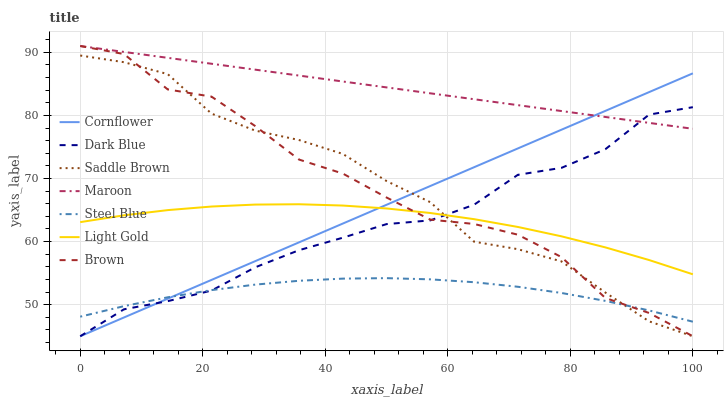Does Steel Blue have the minimum area under the curve?
Answer yes or no. Yes. Does Maroon have the maximum area under the curve?
Answer yes or no. Yes. Does Brown have the minimum area under the curve?
Answer yes or no. No. Does Brown have the maximum area under the curve?
Answer yes or no. No. Is Maroon the smoothest?
Answer yes or no. Yes. Is Brown the roughest?
Answer yes or no. Yes. Is Steel Blue the smoothest?
Answer yes or no. No. Is Steel Blue the roughest?
Answer yes or no. No. Does Cornflower have the lowest value?
Answer yes or no. Yes. Does Steel Blue have the lowest value?
Answer yes or no. No. Does Maroon have the highest value?
Answer yes or no. Yes. Does Steel Blue have the highest value?
Answer yes or no. No. Is Steel Blue less than Light Gold?
Answer yes or no. Yes. Is Maroon greater than Light Gold?
Answer yes or no. Yes. Does Maroon intersect Brown?
Answer yes or no. Yes. Is Maroon less than Brown?
Answer yes or no. No. Is Maroon greater than Brown?
Answer yes or no. No. Does Steel Blue intersect Light Gold?
Answer yes or no. No. 